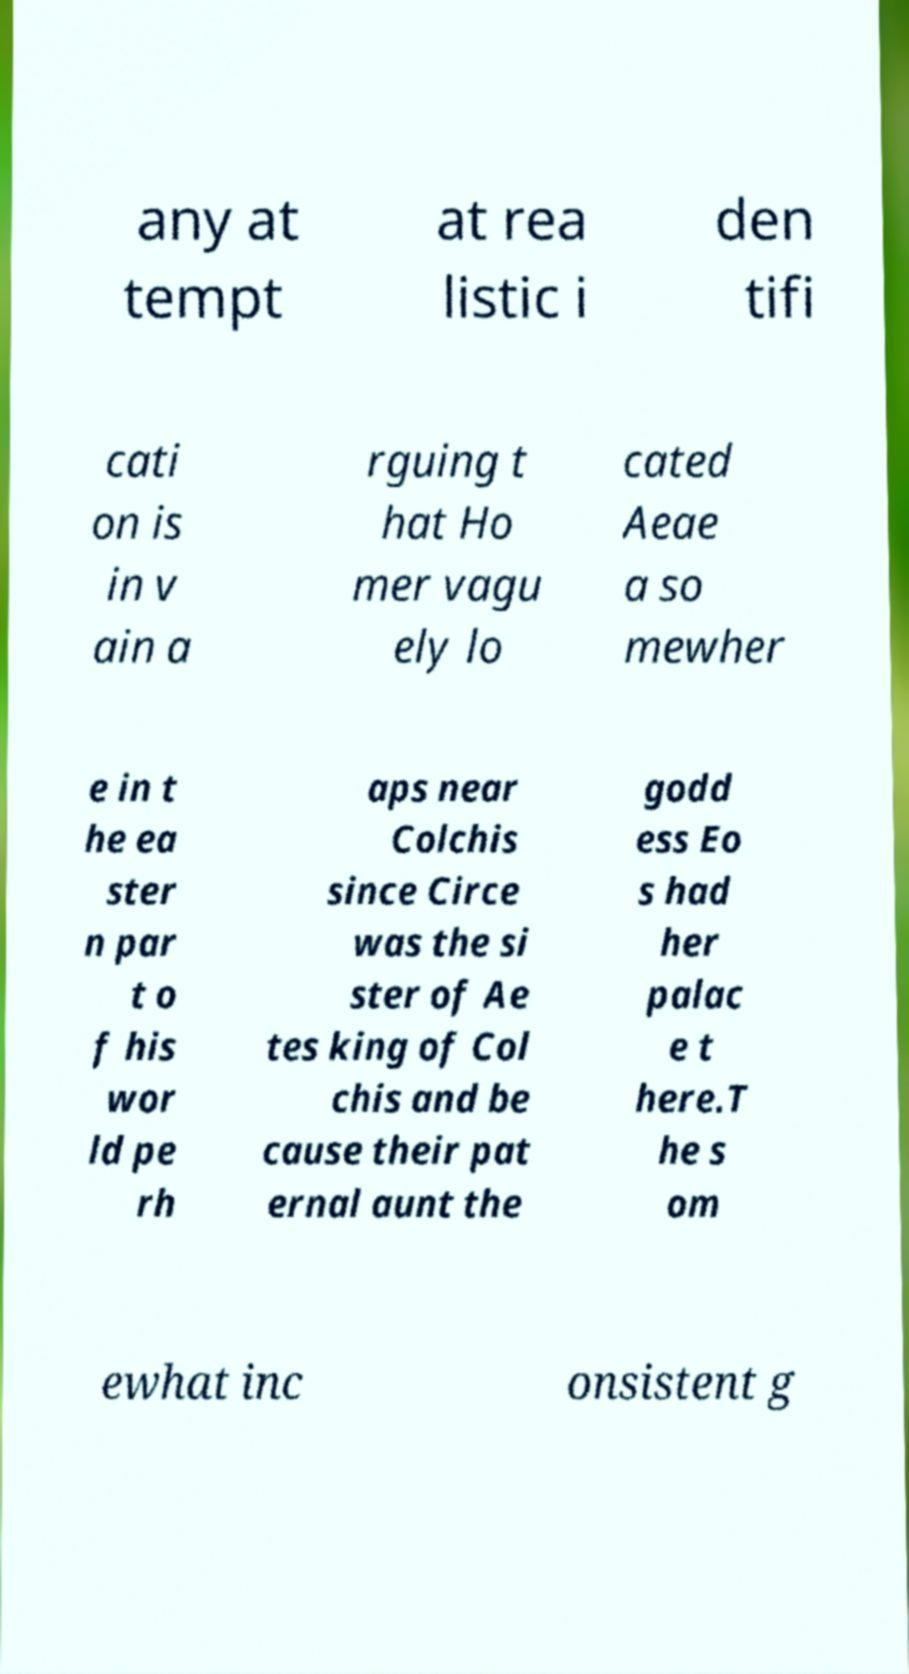Can you accurately transcribe the text from the provided image for me? any at tempt at rea listic i den tifi cati on is in v ain a rguing t hat Ho mer vagu ely lo cated Aeae a so mewher e in t he ea ster n par t o f his wor ld pe rh aps near Colchis since Circe was the si ster of Ae tes king of Col chis and be cause their pat ernal aunt the godd ess Eo s had her palac e t here.T he s om ewhat inc onsistent g 